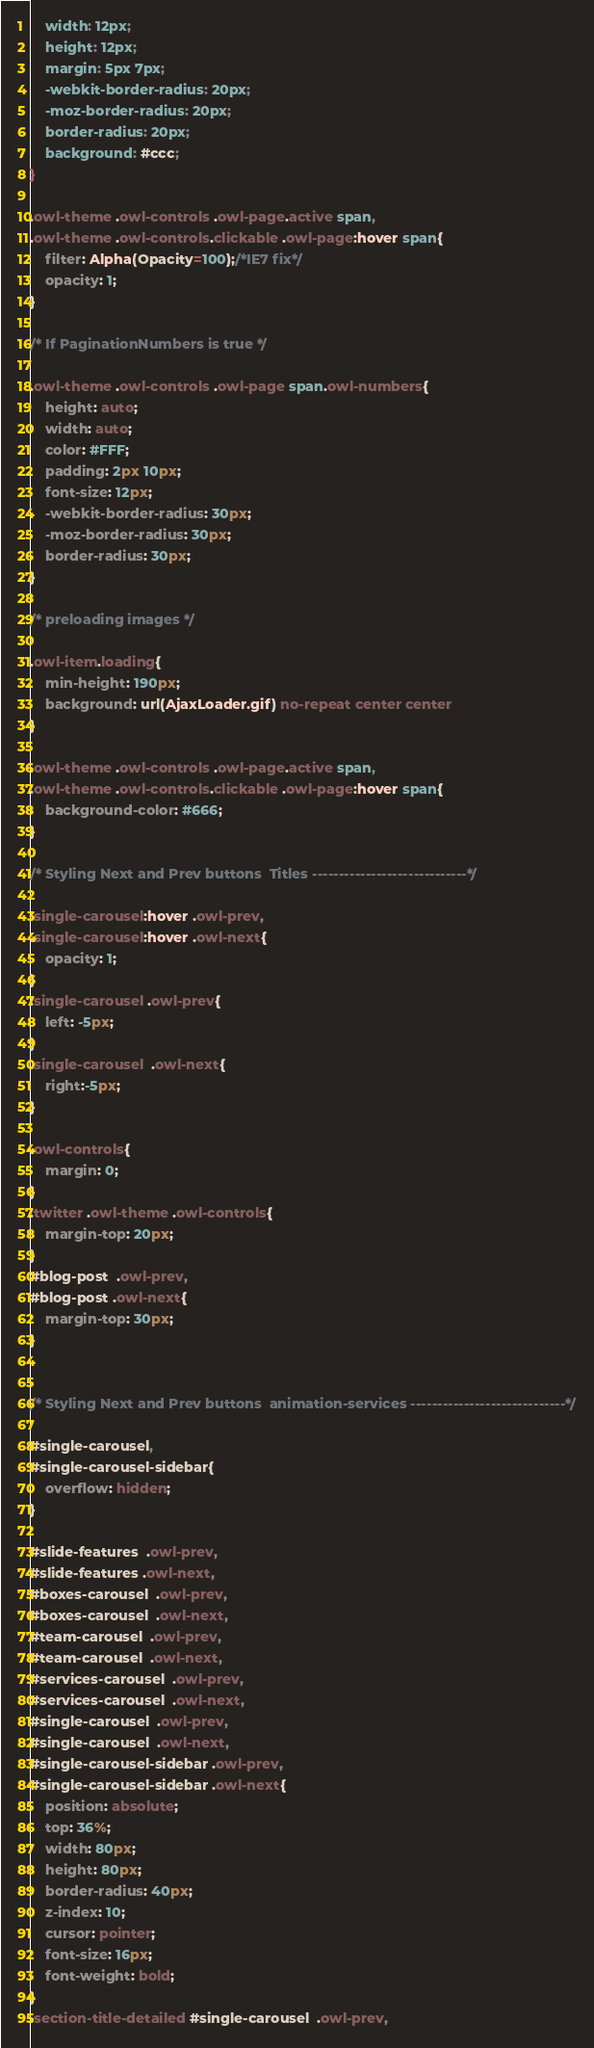<code> <loc_0><loc_0><loc_500><loc_500><_CSS_>	width: 12px;
	height: 12px;
	margin: 5px 7px;
	-webkit-border-radius: 20px;
	-moz-border-radius: 20px;
	border-radius: 20px;
	background: #ccc;
}

.owl-theme .owl-controls .owl-page.active span,
.owl-theme .owl-controls.clickable .owl-page:hover span{
	filter: Alpha(Opacity=100);/*IE7 fix*/
	opacity: 1;
}

/* If PaginationNumbers is true */

.owl-theme .owl-controls .owl-page span.owl-numbers{
	height: auto;
	width: auto;
	color: #FFF;
	padding: 2px 10px;
	font-size: 12px;
	-webkit-border-radius: 30px;
	-moz-border-radius: 30px;
	border-radius: 30px;
}

/* preloading images */

.owl-item.loading{
	min-height: 190px;
	background: url(AjaxLoader.gif) no-repeat center center
}

.owl-theme .owl-controls .owl-page.active span,
.owl-theme .owl-controls.clickable .owl-page:hover span{
	background-color: #666;
}

/* Styling Next and Prev buttons  Titles -----------------------------*/

.single-carousel:hover .owl-prev,
.single-carousel:hover .owl-next{
	opacity: 1;
}
.single-carousel .owl-prev{
	left: -5px;
}
.single-carousel  .owl-next{
	right:-5px;
}

.owl-controls{
	margin: 0;
}
.twitter .owl-theme .owl-controls{
	margin-top: 20px;
}
#blog-post  .owl-prev,
#blog-post .owl-next{	
	margin-top: 30px;
}


/* Styling Next and Prev buttons  animation-services -----------------------------*/

#single-carousel,
#single-carousel-sidebar{
	overflow: hidden;
}

#slide-features  .owl-prev,
#slide-features .owl-next,
#boxes-carousel  .owl-prev,
#boxes-carousel  .owl-next,
#team-carousel  .owl-prev,
#team-carousel  .owl-next,
#services-carousel  .owl-prev,
#services-carousel  .owl-next,
#single-carousel  .owl-prev,
#single-carousel  .owl-next,
#single-carousel-sidebar .owl-prev,
#single-carousel-sidebar .owl-next{	
	position: absolute;
	top: 36%;
	width: 80px;
	height: 80px;
	border-radius: 40px;
	z-index: 10;
	cursor: pointer;
	font-size: 16px;
	font-weight: bold;	
}
.section-title-detailed #single-carousel  .owl-prev,</code> 